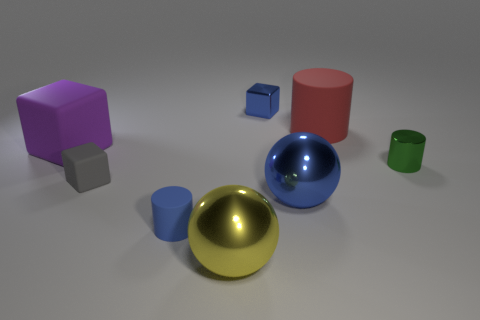There is a gray matte thing that is the same size as the blue shiny block; what is its shape? The object you're referring to is indeed a cube, which is characterized by its six equal square faces, edges that intersect at right angles, and identical vertices. 